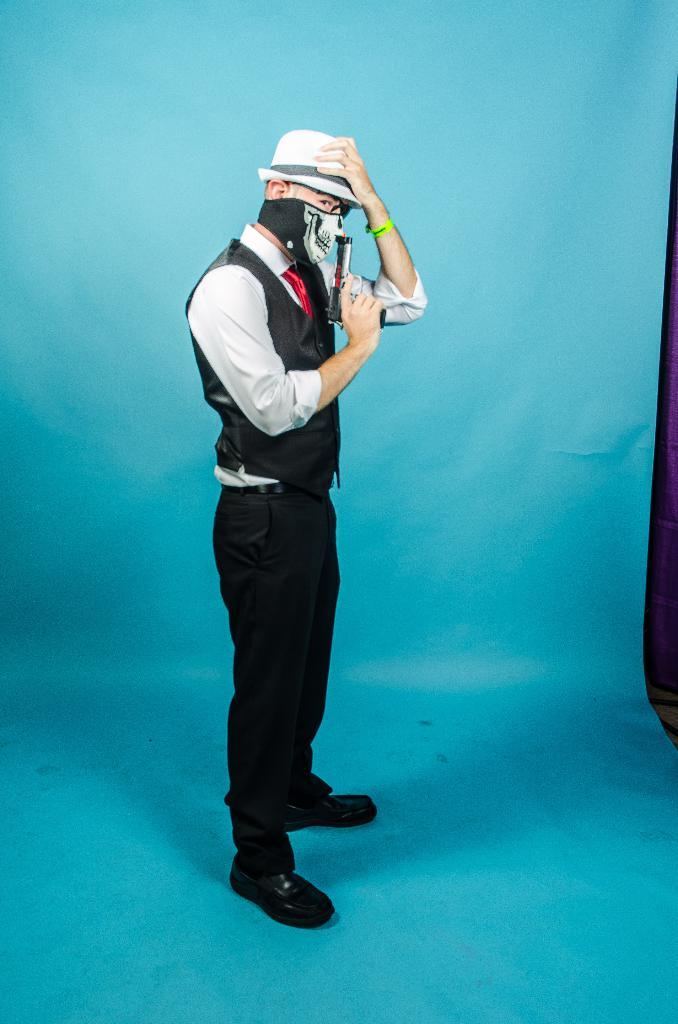What is the person in the image doing? The person is standing in the image and holding a gun. Can you describe the person's attire in the image? The person is wearing a mask and a hat. What is the color of the background in the image? The background of the image is blue. What type of cup can be seen in the person's hand in the image? There is no cup present in the person's hand in the image; they are holding a gun. Can you tell me where the shop is located in the image? There is no shop present in the image; it features a person standing with a gun, wearing a mask and a hat, against a blue background. 